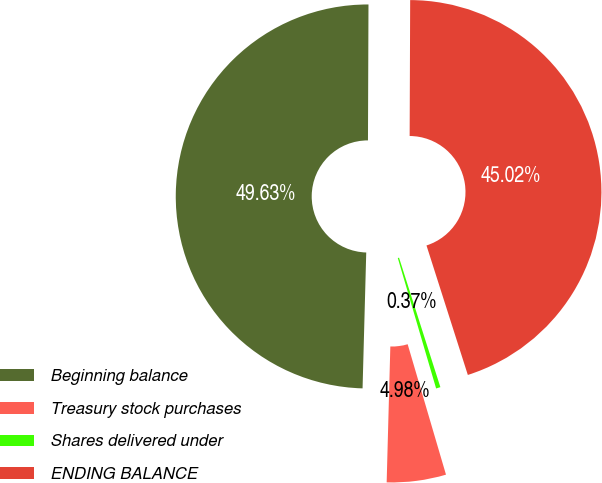Convert chart. <chart><loc_0><loc_0><loc_500><loc_500><pie_chart><fcel>Beginning balance<fcel>Treasury stock purchases<fcel>Shares delivered under<fcel>ENDING BALANCE<nl><fcel>49.63%<fcel>4.98%<fcel>0.37%<fcel>45.02%<nl></chart> 